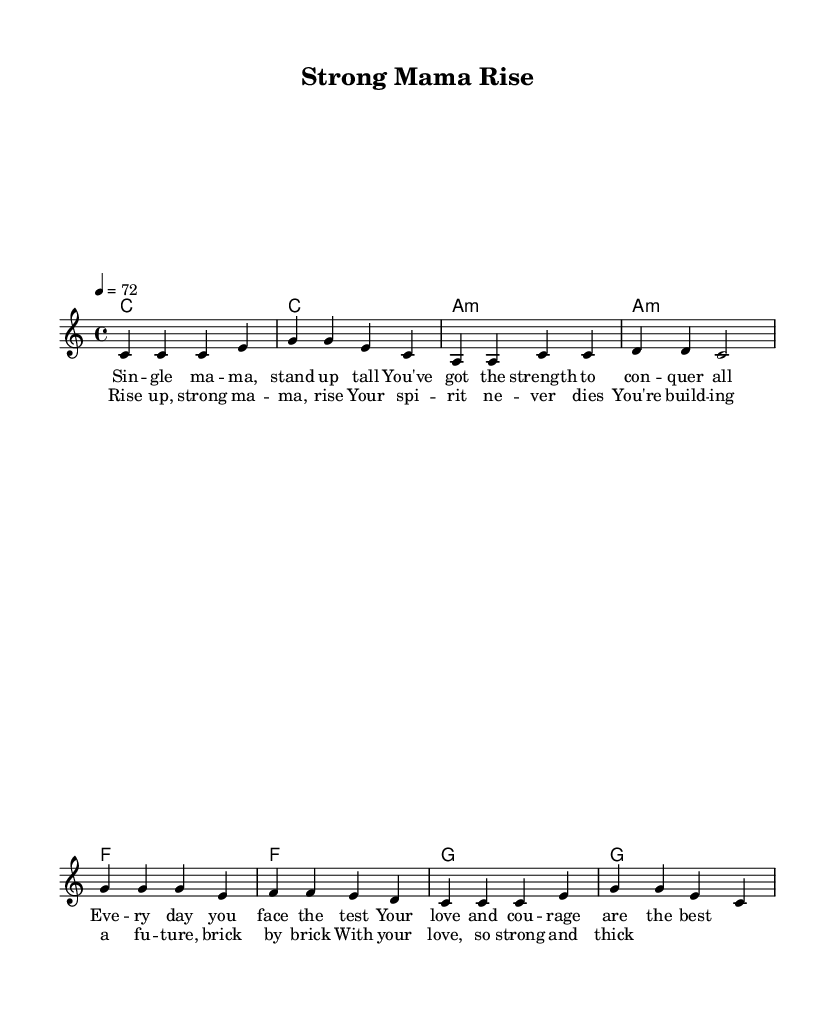What is the key signature of this music? The key signature is C major, which has no sharps or flats.
Answer: C major What is the time signature of this piece? The time signature indicated in the music is 4/4, meaning there are four beats in each measure.
Answer: 4/4 What is the tempo marking for this piece? The tempo marking is indicated as "4 = 72," which means there are 72 quarter-note beats per minute.
Answer: 72 How many measures are there in the verse section? The verse section consists of four measures, as counted from the melody part before the chorus starts.
Answer: 4 What is the first lyric line of the chorus? The first line of the chorus is "Rise up, strong ma -- ma, rise," as seen in the lyrics section corresponding to the melody.
Answer: Rise up, strong ma -- ma, rise What is the harmonic progression used in the chorus? The chorus uses the progression C, A minor, F, G, which can be derived from the chords listed in the harmonies section during the chorus.
Answer: C, A minor, F, G What theme do the lyrics of this song convey? The lyrics convey themes of empowerment and resilience for single mothers, emphasizing their strength and love.
Answer: Empowerment and resilience 